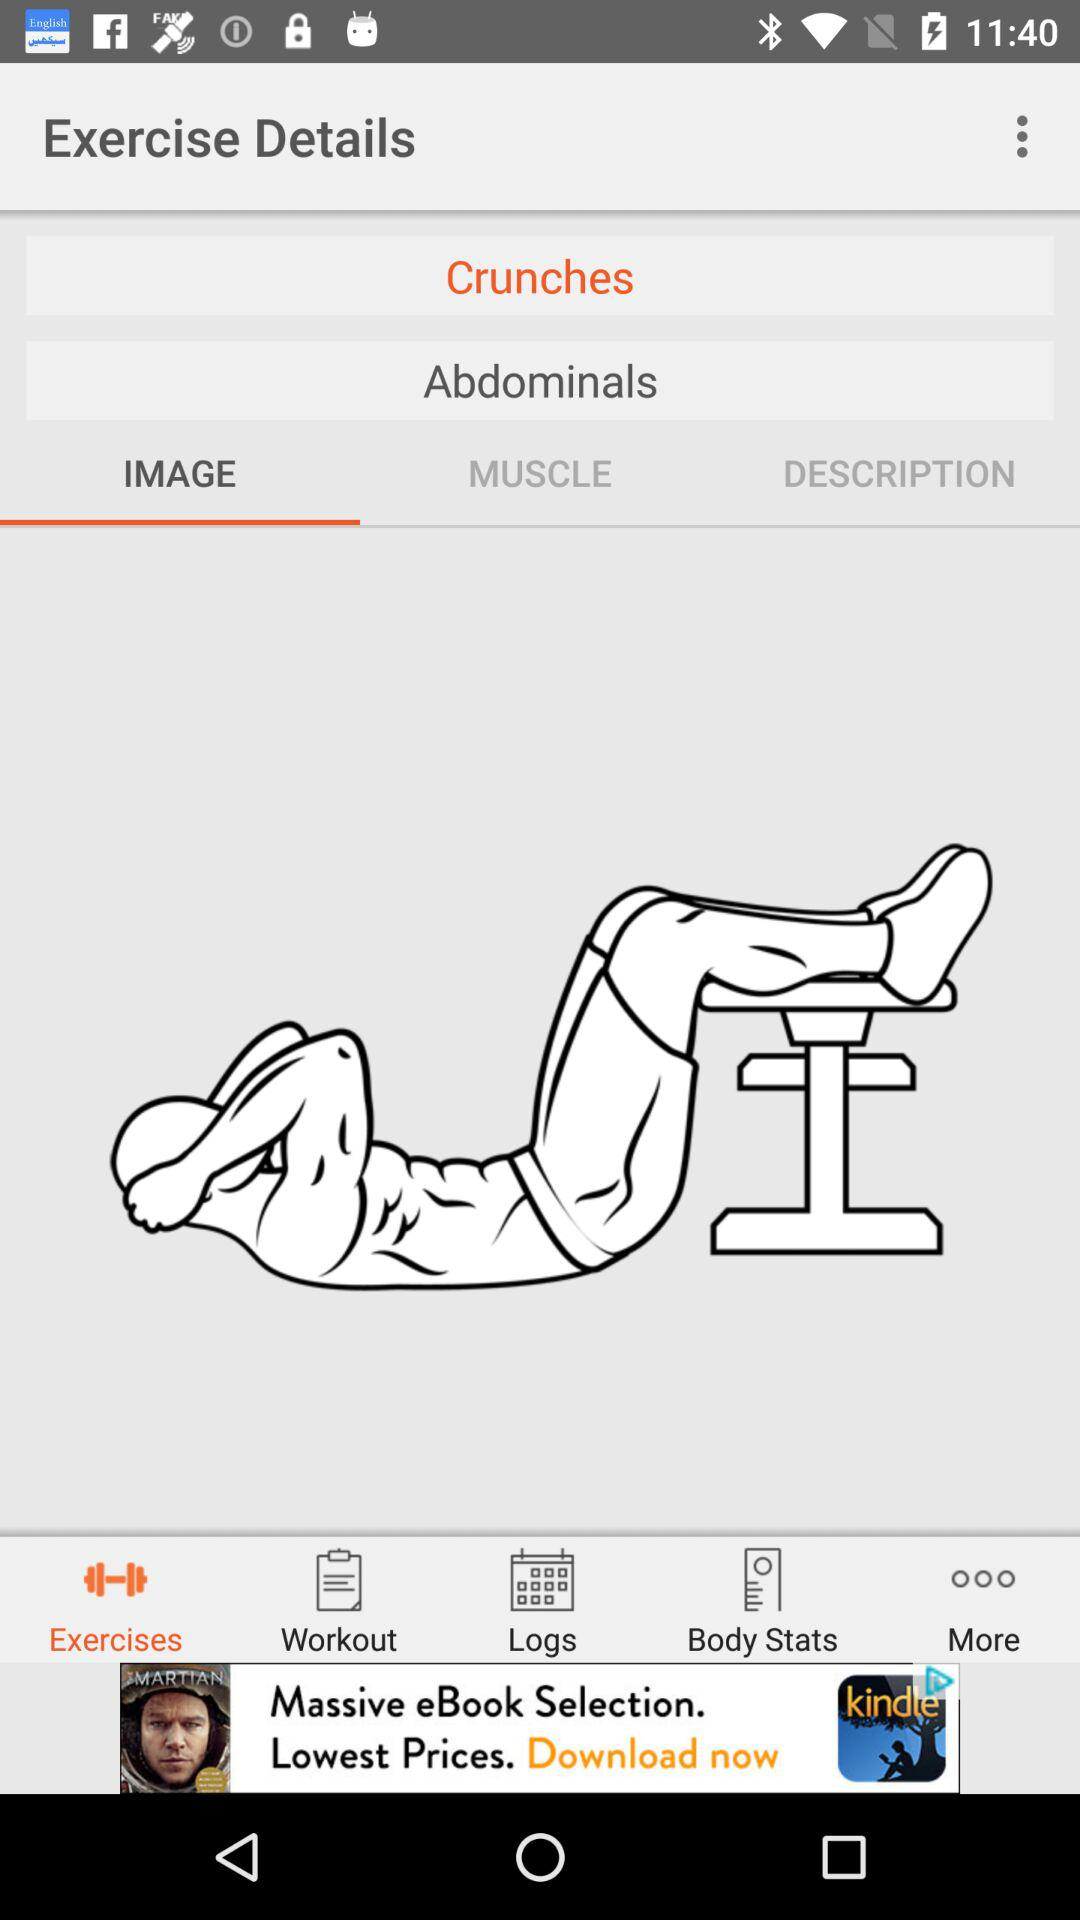What is the exercise name? The exercise name is "Crunches". 